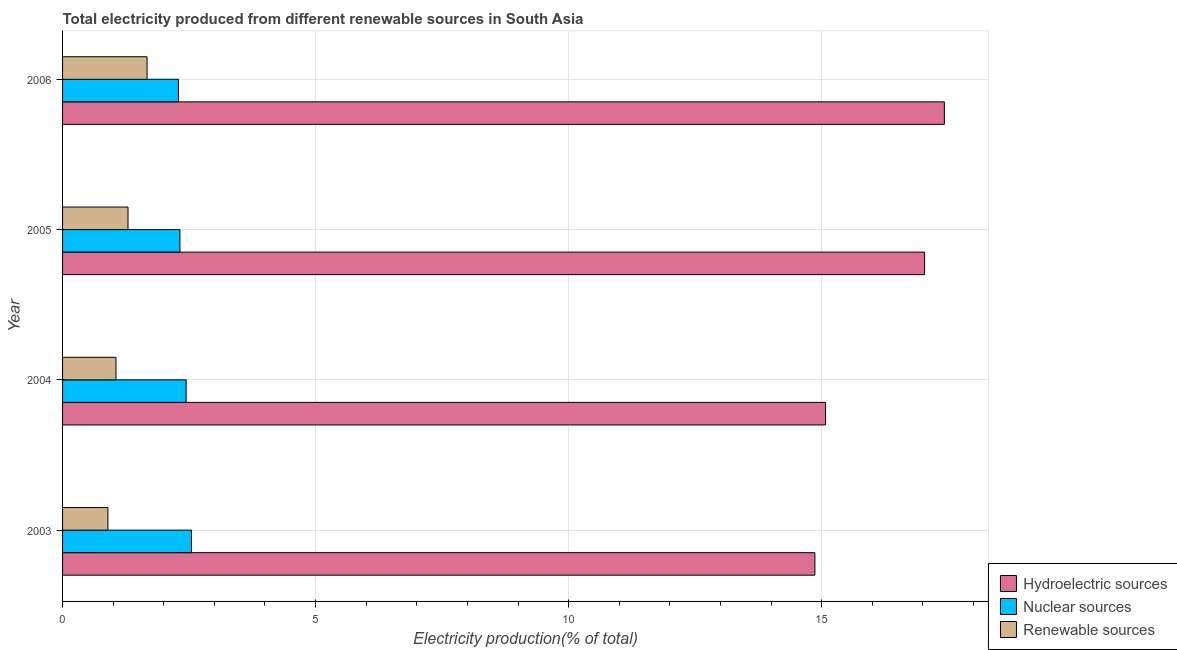How many different coloured bars are there?
Your answer should be compact. 3. How many groups of bars are there?
Your response must be concise. 4. How many bars are there on the 1st tick from the top?
Offer a terse response. 3. What is the label of the 4th group of bars from the top?
Provide a succinct answer. 2003. In how many cases, is the number of bars for a given year not equal to the number of legend labels?
Provide a succinct answer. 0. What is the percentage of electricity produced by renewable sources in 2003?
Your answer should be very brief. 0.9. Across all years, what is the maximum percentage of electricity produced by renewable sources?
Your answer should be very brief. 1.67. Across all years, what is the minimum percentage of electricity produced by nuclear sources?
Offer a terse response. 2.29. In which year was the percentage of electricity produced by renewable sources maximum?
Offer a terse response. 2006. What is the total percentage of electricity produced by nuclear sources in the graph?
Your response must be concise. 9.6. What is the difference between the percentage of electricity produced by hydroelectric sources in 2003 and that in 2005?
Ensure brevity in your answer.  -2.17. What is the difference between the percentage of electricity produced by renewable sources in 2006 and the percentage of electricity produced by nuclear sources in 2003?
Make the answer very short. -0.88. What is the average percentage of electricity produced by hydroelectric sources per year?
Your answer should be compact. 16.1. In the year 2004, what is the difference between the percentage of electricity produced by nuclear sources and percentage of electricity produced by hydroelectric sources?
Your answer should be very brief. -12.64. What is the ratio of the percentage of electricity produced by renewable sources in 2005 to that in 2006?
Provide a succinct answer. 0.78. Is the difference between the percentage of electricity produced by nuclear sources in 2003 and 2004 greater than the difference between the percentage of electricity produced by renewable sources in 2003 and 2004?
Provide a short and direct response. Yes. What is the difference between the highest and the second highest percentage of electricity produced by hydroelectric sources?
Ensure brevity in your answer.  0.39. What is the difference between the highest and the lowest percentage of electricity produced by renewable sources?
Offer a terse response. 0.77. In how many years, is the percentage of electricity produced by nuclear sources greater than the average percentage of electricity produced by nuclear sources taken over all years?
Keep it short and to the point. 2. Is the sum of the percentage of electricity produced by renewable sources in 2003 and 2004 greater than the maximum percentage of electricity produced by nuclear sources across all years?
Offer a very short reply. No. What does the 3rd bar from the top in 2003 represents?
Give a very brief answer. Hydroelectric sources. What does the 2nd bar from the bottom in 2004 represents?
Provide a succinct answer. Nuclear sources. How many bars are there?
Keep it short and to the point. 12. Are all the bars in the graph horizontal?
Your response must be concise. Yes. Are the values on the major ticks of X-axis written in scientific E-notation?
Provide a short and direct response. No. Does the graph contain any zero values?
Provide a short and direct response. No. Does the graph contain grids?
Offer a terse response. Yes. How are the legend labels stacked?
Provide a short and direct response. Vertical. What is the title of the graph?
Your answer should be very brief. Total electricity produced from different renewable sources in South Asia. What is the label or title of the X-axis?
Offer a very short reply. Electricity production(% of total). What is the Electricity production(% of total) in Hydroelectric sources in 2003?
Make the answer very short. 14.87. What is the Electricity production(% of total) of Nuclear sources in 2003?
Keep it short and to the point. 2.55. What is the Electricity production(% of total) of Renewable sources in 2003?
Keep it short and to the point. 0.9. What is the Electricity production(% of total) of Hydroelectric sources in 2004?
Your answer should be compact. 15.08. What is the Electricity production(% of total) of Nuclear sources in 2004?
Provide a succinct answer. 2.44. What is the Electricity production(% of total) of Renewable sources in 2004?
Make the answer very short. 1.06. What is the Electricity production(% of total) of Hydroelectric sources in 2005?
Your answer should be very brief. 17.04. What is the Electricity production(% of total) in Nuclear sources in 2005?
Make the answer very short. 2.32. What is the Electricity production(% of total) in Renewable sources in 2005?
Keep it short and to the point. 1.29. What is the Electricity production(% of total) in Hydroelectric sources in 2006?
Give a very brief answer. 17.43. What is the Electricity production(% of total) in Nuclear sources in 2006?
Offer a very short reply. 2.29. What is the Electricity production(% of total) of Renewable sources in 2006?
Provide a succinct answer. 1.67. Across all years, what is the maximum Electricity production(% of total) in Hydroelectric sources?
Your response must be concise. 17.43. Across all years, what is the maximum Electricity production(% of total) in Nuclear sources?
Ensure brevity in your answer.  2.55. Across all years, what is the maximum Electricity production(% of total) in Renewable sources?
Offer a very short reply. 1.67. Across all years, what is the minimum Electricity production(% of total) of Hydroelectric sources?
Provide a succinct answer. 14.87. Across all years, what is the minimum Electricity production(% of total) of Nuclear sources?
Your answer should be very brief. 2.29. Across all years, what is the minimum Electricity production(% of total) in Renewable sources?
Ensure brevity in your answer.  0.9. What is the total Electricity production(% of total) in Hydroelectric sources in the graph?
Your answer should be compact. 64.41. What is the total Electricity production(% of total) of Nuclear sources in the graph?
Your response must be concise. 9.6. What is the total Electricity production(% of total) of Renewable sources in the graph?
Offer a very short reply. 4.91. What is the difference between the Electricity production(% of total) in Hydroelectric sources in 2003 and that in 2004?
Provide a succinct answer. -0.21. What is the difference between the Electricity production(% of total) of Nuclear sources in 2003 and that in 2004?
Provide a succinct answer. 0.11. What is the difference between the Electricity production(% of total) in Renewable sources in 2003 and that in 2004?
Your answer should be compact. -0.16. What is the difference between the Electricity production(% of total) in Hydroelectric sources in 2003 and that in 2005?
Offer a terse response. -2.17. What is the difference between the Electricity production(% of total) of Nuclear sources in 2003 and that in 2005?
Ensure brevity in your answer.  0.23. What is the difference between the Electricity production(% of total) of Renewable sources in 2003 and that in 2005?
Make the answer very short. -0.4. What is the difference between the Electricity production(% of total) of Hydroelectric sources in 2003 and that in 2006?
Give a very brief answer. -2.56. What is the difference between the Electricity production(% of total) in Nuclear sources in 2003 and that in 2006?
Keep it short and to the point. 0.26. What is the difference between the Electricity production(% of total) in Renewable sources in 2003 and that in 2006?
Make the answer very short. -0.77. What is the difference between the Electricity production(% of total) in Hydroelectric sources in 2004 and that in 2005?
Ensure brevity in your answer.  -1.96. What is the difference between the Electricity production(% of total) of Nuclear sources in 2004 and that in 2005?
Provide a succinct answer. 0.12. What is the difference between the Electricity production(% of total) of Renewable sources in 2004 and that in 2005?
Give a very brief answer. -0.24. What is the difference between the Electricity production(% of total) of Hydroelectric sources in 2004 and that in 2006?
Give a very brief answer. -2.35. What is the difference between the Electricity production(% of total) of Nuclear sources in 2004 and that in 2006?
Make the answer very short. 0.15. What is the difference between the Electricity production(% of total) in Renewable sources in 2004 and that in 2006?
Your answer should be very brief. -0.61. What is the difference between the Electricity production(% of total) in Hydroelectric sources in 2005 and that in 2006?
Offer a very short reply. -0.39. What is the difference between the Electricity production(% of total) in Nuclear sources in 2005 and that in 2006?
Offer a terse response. 0.03. What is the difference between the Electricity production(% of total) of Renewable sources in 2005 and that in 2006?
Your answer should be very brief. -0.38. What is the difference between the Electricity production(% of total) of Hydroelectric sources in 2003 and the Electricity production(% of total) of Nuclear sources in 2004?
Provide a short and direct response. 12.42. What is the difference between the Electricity production(% of total) of Hydroelectric sources in 2003 and the Electricity production(% of total) of Renewable sources in 2004?
Offer a terse response. 13.81. What is the difference between the Electricity production(% of total) in Nuclear sources in 2003 and the Electricity production(% of total) in Renewable sources in 2004?
Provide a succinct answer. 1.49. What is the difference between the Electricity production(% of total) in Hydroelectric sources in 2003 and the Electricity production(% of total) in Nuclear sources in 2005?
Your response must be concise. 12.55. What is the difference between the Electricity production(% of total) of Hydroelectric sources in 2003 and the Electricity production(% of total) of Renewable sources in 2005?
Keep it short and to the point. 13.57. What is the difference between the Electricity production(% of total) in Nuclear sources in 2003 and the Electricity production(% of total) in Renewable sources in 2005?
Give a very brief answer. 1.25. What is the difference between the Electricity production(% of total) of Hydroelectric sources in 2003 and the Electricity production(% of total) of Nuclear sources in 2006?
Make the answer very short. 12.58. What is the difference between the Electricity production(% of total) of Hydroelectric sources in 2003 and the Electricity production(% of total) of Renewable sources in 2006?
Offer a terse response. 13.2. What is the difference between the Electricity production(% of total) of Nuclear sources in 2003 and the Electricity production(% of total) of Renewable sources in 2006?
Offer a very short reply. 0.88. What is the difference between the Electricity production(% of total) in Hydroelectric sources in 2004 and the Electricity production(% of total) in Nuclear sources in 2005?
Your answer should be compact. 12.76. What is the difference between the Electricity production(% of total) of Hydroelectric sources in 2004 and the Electricity production(% of total) of Renewable sources in 2005?
Ensure brevity in your answer.  13.78. What is the difference between the Electricity production(% of total) in Nuclear sources in 2004 and the Electricity production(% of total) in Renewable sources in 2005?
Your answer should be very brief. 1.15. What is the difference between the Electricity production(% of total) in Hydroelectric sources in 2004 and the Electricity production(% of total) in Nuclear sources in 2006?
Make the answer very short. 12.79. What is the difference between the Electricity production(% of total) of Hydroelectric sources in 2004 and the Electricity production(% of total) of Renewable sources in 2006?
Your answer should be compact. 13.41. What is the difference between the Electricity production(% of total) of Nuclear sources in 2004 and the Electricity production(% of total) of Renewable sources in 2006?
Offer a very short reply. 0.77. What is the difference between the Electricity production(% of total) in Hydroelectric sources in 2005 and the Electricity production(% of total) in Nuclear sources in 2006?
Keep it short and to the point. 14.74. What is the difference between the Electricity production(% of total) in Hydroelectric sources in 2005 and the Electricity production(% of total) in Renewable sources in 2006?
Offer a terse response. 15.37. What is the difference between the Electricity production(% of total) of Nuclear sources in 2005 and the Electricity production(% of total) of Renewable sources in 2006?
Ensure brevity in your answer.  0.65. What is the average Electricity production(% of total) in Hydroelectric sources per year?
Provide a succinct answer. 16.1. What is the average Electricity production(% of total) in Nuclear sources per year?
Your answer should be very brief. 2.4. What is the average Electricity production(% of total) of Renewable sources per year?
Your response must be concise. 1.23. In the year 2003, what is the difference between the Electricity production(% of total) in Hydroelectric sources and Electricity production(% of total) in Nuclear sources?
Ensure brevity in your answer.  12.32. In the year 2003, what is the difference between the Electricity production(% of total) in Hydroelectric sources and Electricity production(% of total) in Renewable sources?
Provide a short and direct response. 13.97. In the year 2003, what is the difference between the Electricity production(% of total) of Nuclear sources and Electricity production(% of total) of Renewable sources?
Your answer should be very brief. 1.65. In the year 2004, what is the difference between the Electricity production(% of total) in Hydroelectric sources and Electricity production(% of total) in Nuclear sources?
Offer a very short reply. 12.64. In the year 2004, what is the difference between the Electricity production(% of total) in Hydroelectric sources and Electricity production(% of total) in Renewable sources?
Keep it short and to the point. 14.02. In the year 2004, what is the difference between the Electricity production(% of total) of Nuclear sources and Electricity production(% of total) of Renewable sources?
Your answer should be compact. 1.39. In the year 2005, what is the difference between the Electricity production(% of total) in Hydroelectric sources and Electricity production(% of total) in Nuclear sources?
Your answer should be compact. 14.72. In the year 2005, what is the difference between the Electricity production(% of total) in Hydroelectric sources and Electricity production(% of total) in Renewable sources?
Provide a succinct answer. 15.74. In the year 2006, what is the difference between the Electricity production(% of total) in Hydroelectric sources and Electricity production(% of total) in Nuclear sources?
Your response must be concise. 15.13. In the year 2006, what is the difference between the Electricity production(% of total) of Hydroelectric sources and Electricity production(% of total) of Renewable sources?
Your answer should be very brief. 15.76. In the year 2006, what is the difference between the Electricity production(% of total) in Nuclear sources and Electricity production(% of total) in Renewable sources?
Make the answer very short. 0.62. What is the ratio of the Electricity production(% of total) of Nuclear sources in 2003 to that in 2004?
Offer a very short reply. 1.04. What is the ratio of the Electricity production(% of total) in Renewable sources in 2003 to that in 2004?
Keep it short and to the point. 0.85. What is the ratio of the Electricity production(% of total) in Hydroelectric sources in 2003 to that in 2005?
Make the answer very short. 0.87. What is the ratio of the Electricity production(% of total) of Nuclear sources in 2003 to that in 2005?
Offer a terse response. 1.1. What is the ratio of the Electricity production(% of total) in Renewable sources in 2003 to that in 2005?
Your response must be concise. 0.69. What is the ratio of the Electricity production(% of total) of Hydroelectric sources in 2003 to that in 2006?
Your answer should be very brief. 0.85. What is the ratio of the Electricity production(% of total) in Nuclear sources in 2003 to that in 2006?
Offer a very short reply. 1.11. What is the ratio of the Electricity production(% of total) of Renewable sources in 2003 to that in 2006?
Offer a very short reply. 0.54. What is the ratio of the Electricity production(% of total) of Hydroelectric sources in 2004 to that in 2005?
Your response must be concise. 0.89. What is the ratio of the Electricity production(% of total) in Nuclear sources in 2004 to that in 2005?
Keep it short and to the point. 1.05. What is the ratio of the Electricity production(% of total) in Renewable sources in 2004 to that in 2005?
Your answer should be very brief. 0.82. What is the ratio of the Electricity production(% of total) in Hydroelectric sources in 2004 to that in 2006?
Keep it short and to the point. 0.87. What is the ratio of the Electricity production(% of total) of Nuclear sources in 2004 to that in 2006?
Ensure brevity in your answer.  1.07. What is the ratio of the Electricity production(% of total) of Renewable sources in 2004 to that in 2006?
Provide a short and direct response. 0.63. What is the ratio of the Electricity production(% of total) in Hydroelectric sources in 2005 to that in 2006?
Your answer should be compact. 0.98. What is the ratio of the Electricity production(% of total) of Nuclear sources in 2005 to that in 2006?
Offer a terse response. 1.01. What is the ratio of the Electricity production(% of total) of Renewable sources in 2005 to that in 2006?
Offer a very short reply. 0.77. What is the difference between the highest and the second highest Electricity production(% of total) of Hydroelectric sources?
Your answer should be compact. 0.39. What is the difference between the highest and the second highest Electricity production(% of total) of Nuclear sources?
Keep it short and to the point. 0.11. What is the difference between the highest and the second highest Electricity production(% of total) of Renewable sources?
Provide a succinct answer. 0.38. What is the difference between the highest and the lowest Electricity production(% of total) in Hydroelectric sources?
Make the answer very short. 2.56. What is the difference between the highest and the lowest Electricity production(% of total) in Nuclear sources?
Provide a succinct answer. 0.26. What is the difference between the highest and the lowest Electricity production(% of total) in Renewable sources?
Your response must be concise. 0.77. 